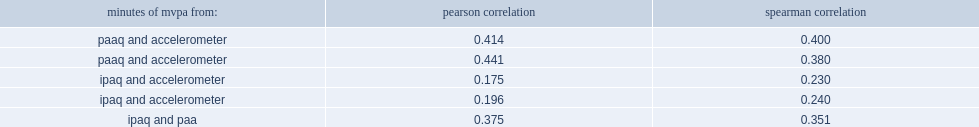What was the pearson correlation between the ipaq and paaq estimates? 0.375. 